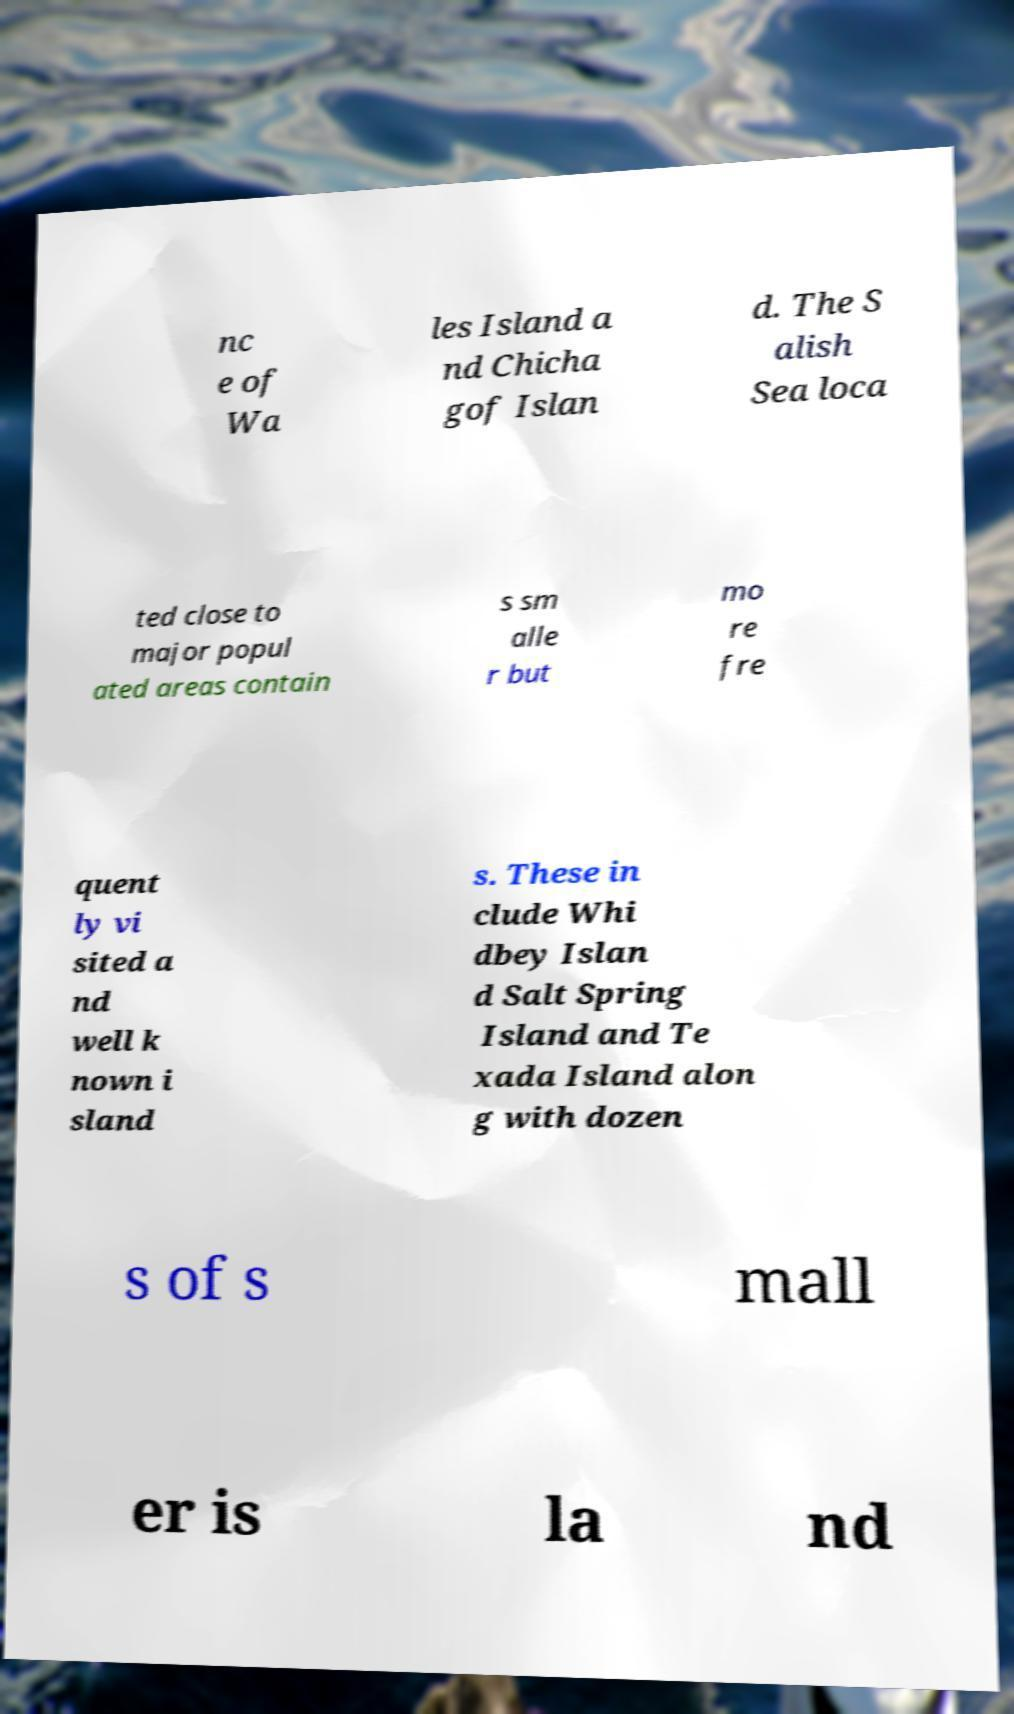For documentation purposes, I need the text within this image transcribed. Could you provide that? nc e of Wa les Island a nd Chicha gof Islan d. The S alish Sea loca ted close to major popul ated areas contain s sm alle r but mo re fre quent ly vi sited a nd well k nown i sland s. These in clude Whi dbey Islan d Salt Spring Island and Te xada Island alon g with dozen s of s mall er is la nd 